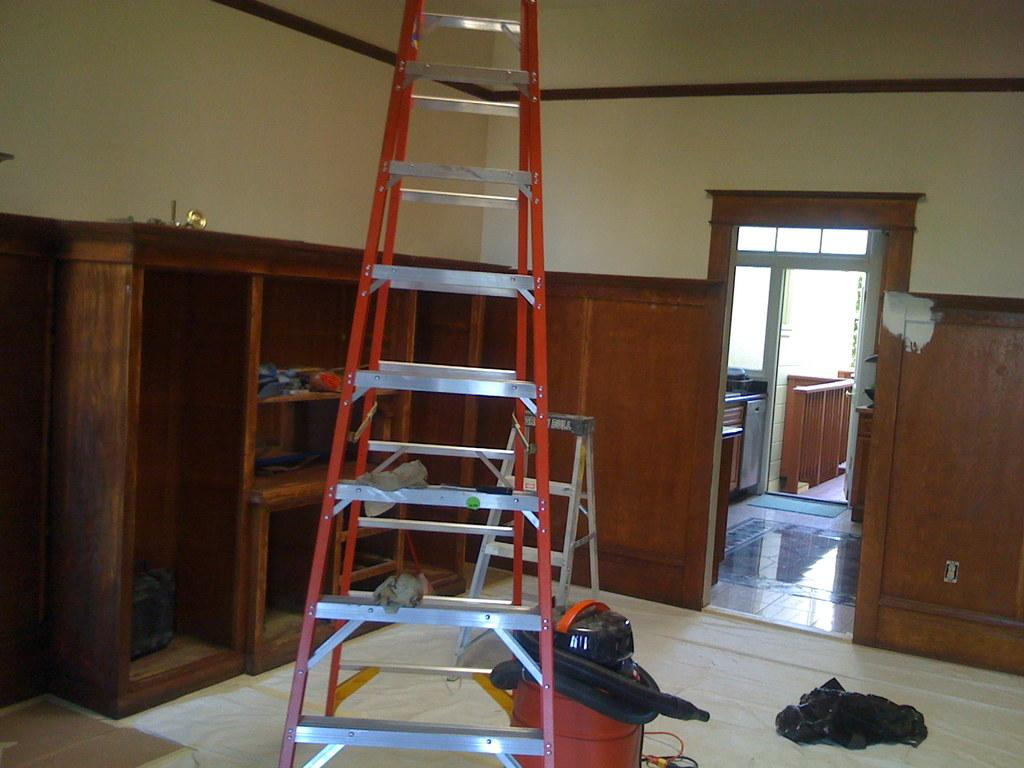What is one of the objects in the room that can be used for climbing or reaching high places? There is a ladder in the room. What object in the room can be used to hold or display items? There are shelves in the room. What object in the room can be used to support or hold other objects? There is a stand in the room. What else can be found on the floor in the room? There are other objects on the floor in the room. How many pigs are visible on the shelves in the room? There are no pigs present in the image, as it only shows a ladder, a stand, shelves, and other objects on the floor. 